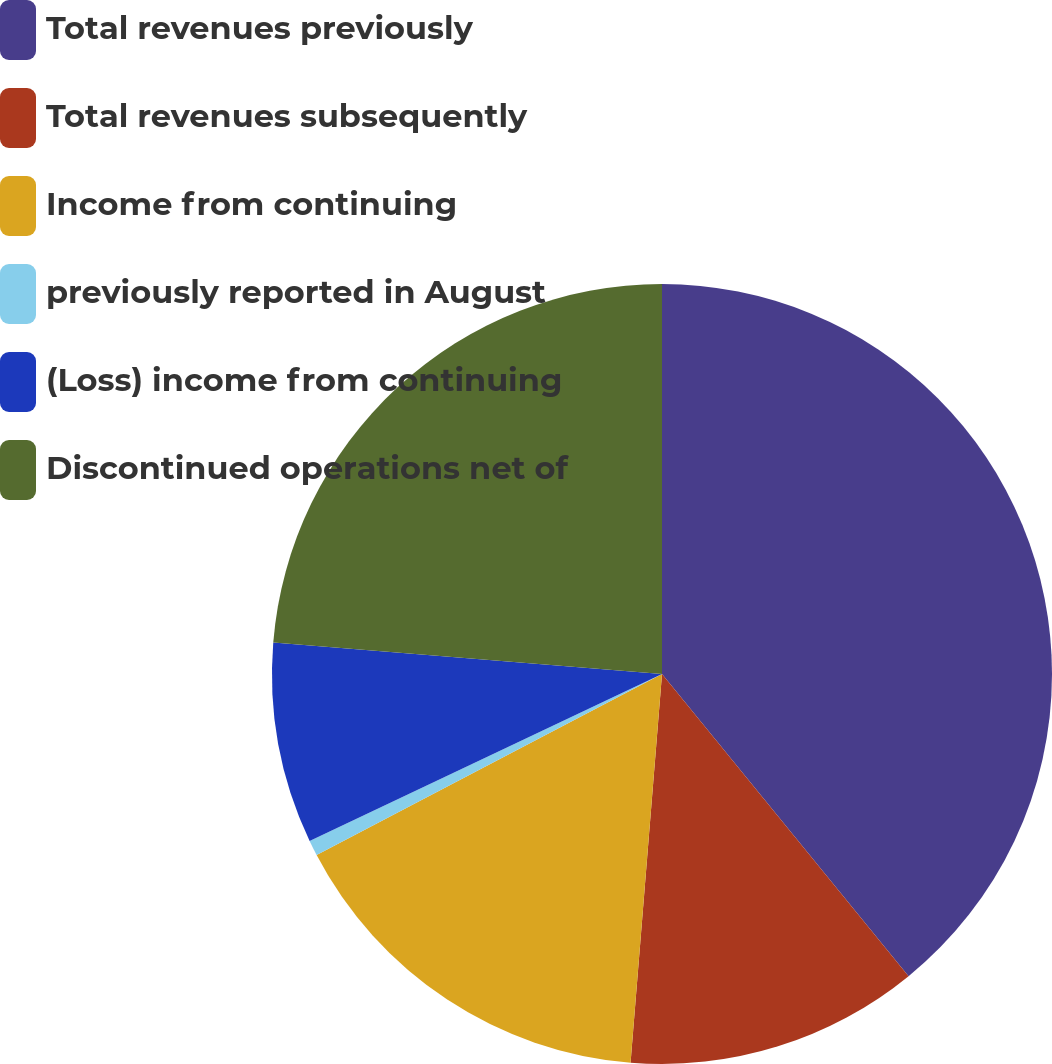<chart> <loc_0><loc_0><loc_500><loc_500><pie_chart><fcel>Total revenues previously<fcel>Total revenues subsequently<fcel>Income from continuing<fcel>previously reported in August<fcel>(Loss) income from continuing<fcel>Discontinued operations net of<nl><fcel>39.11%<fcel>12.18%<fcel>16.03%<fcel>0.64%<fcel>8.33%<fcel>23.72%<nl></chart> 